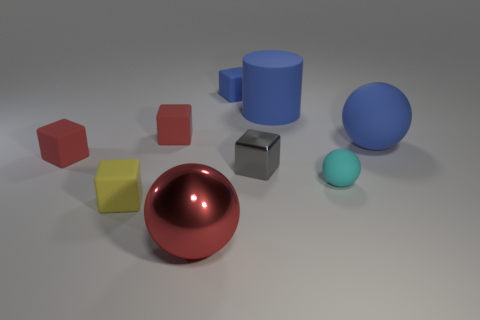There is a tiny thing behind the large blue rubber cylinder; is it the same shape as the metallic object to the right of the tiny blue rubber block? Yes, both the object behind the large blue cylinder and the metallic object to the right of the tiny blue rubber block have a cubic shape, characterized by their six square faces and angular edges. 